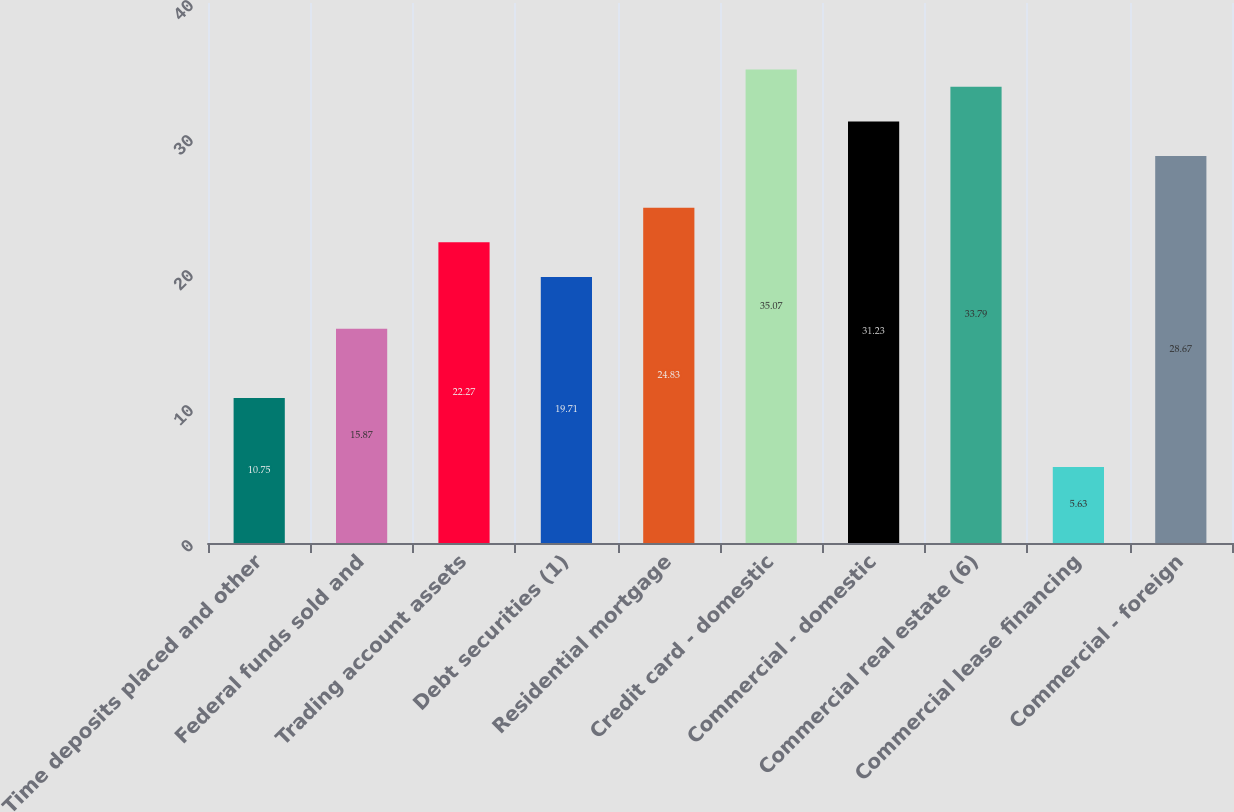Convert chart. <chart><loc_0><loc_0><loc_500><loc_500><bar_chart><fcel>Time deposits placed and other<fcel>Federal funds sold and<fcel>Trading account assets<fcel>Debt securities (1)<fcel>Residential mortgage<fcel>Credit card - domestic<fcel>Commercial - domestic<fcel>Commercial real estate (6)<fcel>Commercial lease financing<fcel>Commercial - foreign<nl><fcel>10.75<fcel>15.87<fcel>22.27<fcel>19.71<fcel>24.83<fcel>35.07<fcel>31.23<fcel>33.79<fcel>5.63<fcel>28.67<nl></chart> 